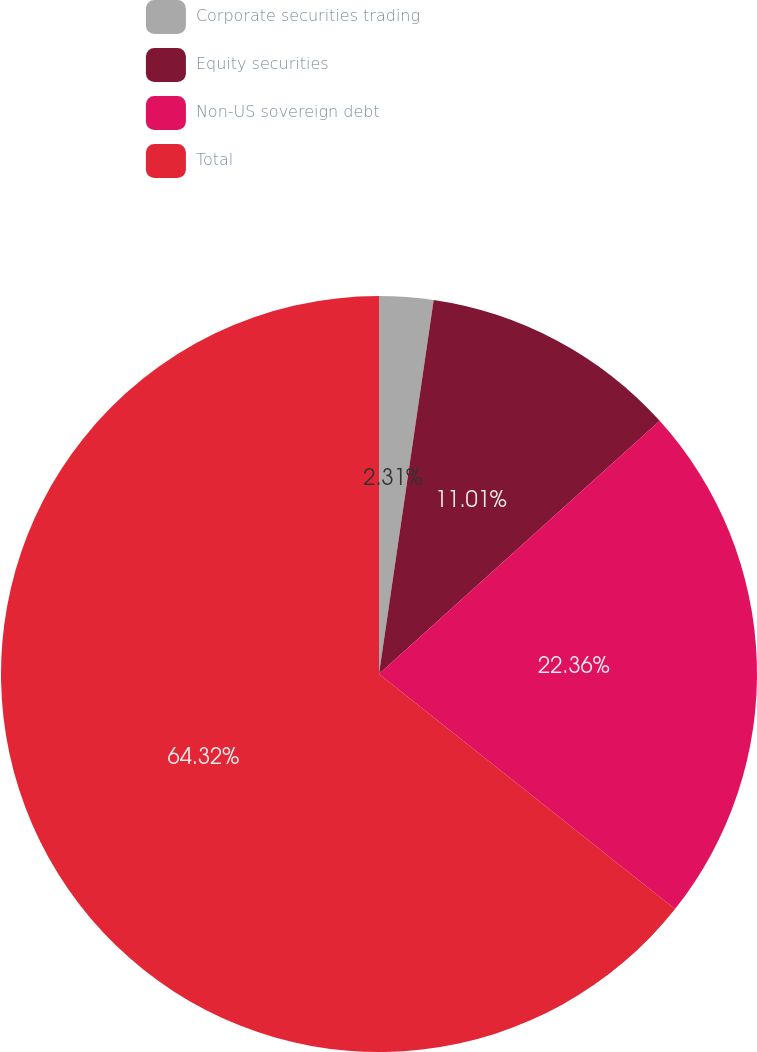Convert chart. <chart><loc_0><loc_0><loc_500><loc_500><pie_chart><fcel>Corporate securities trading<fcel>Equity securities<fcel>Non-US sovereign debt<fcel>Total<nl><fcel>2.31%<fcel>11.01%<fcel>22.36%<fcel>64.32%<nl></chart> 